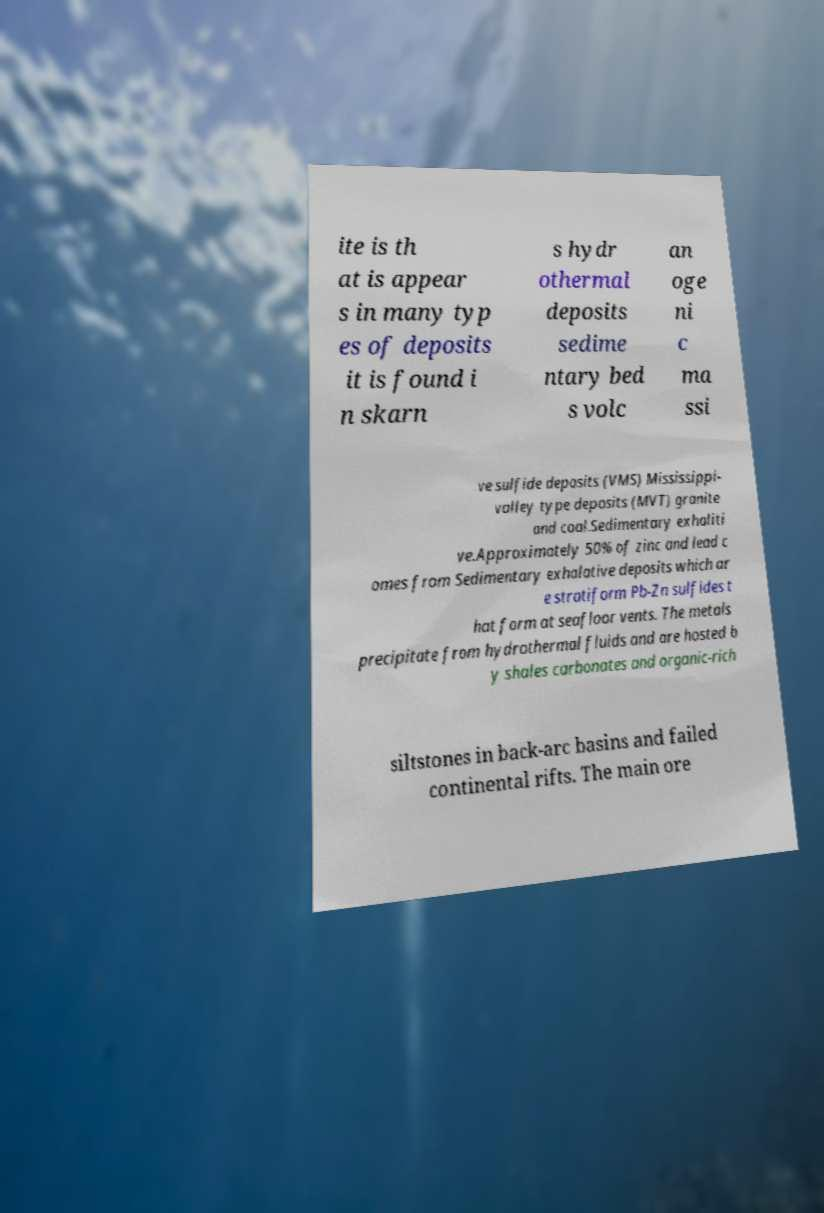I need the written content from this picture converted into text. Can you do that? ite is th at is appear s in many typ es of deposits it is found i n skarn s hydr othermal deposits sedime ntary bed s volc an oge ni c ma ssi ve sulfide deposits (VMS) Mississippi- valley type deposits (MVT) granite and coal.Sedimentary exhaliti ve.Approximately 50% of zinc and lead c omes from Sedimentary exhalative deposits which ar e stratiform Pb-Zn sulfides t hat form at seafloor vents. The metals precipitate from hydrothermal fluids and are hosted b y shales carbonates and organic-rich siltstones in back-arc basins and failed continental rifts. The main ore 